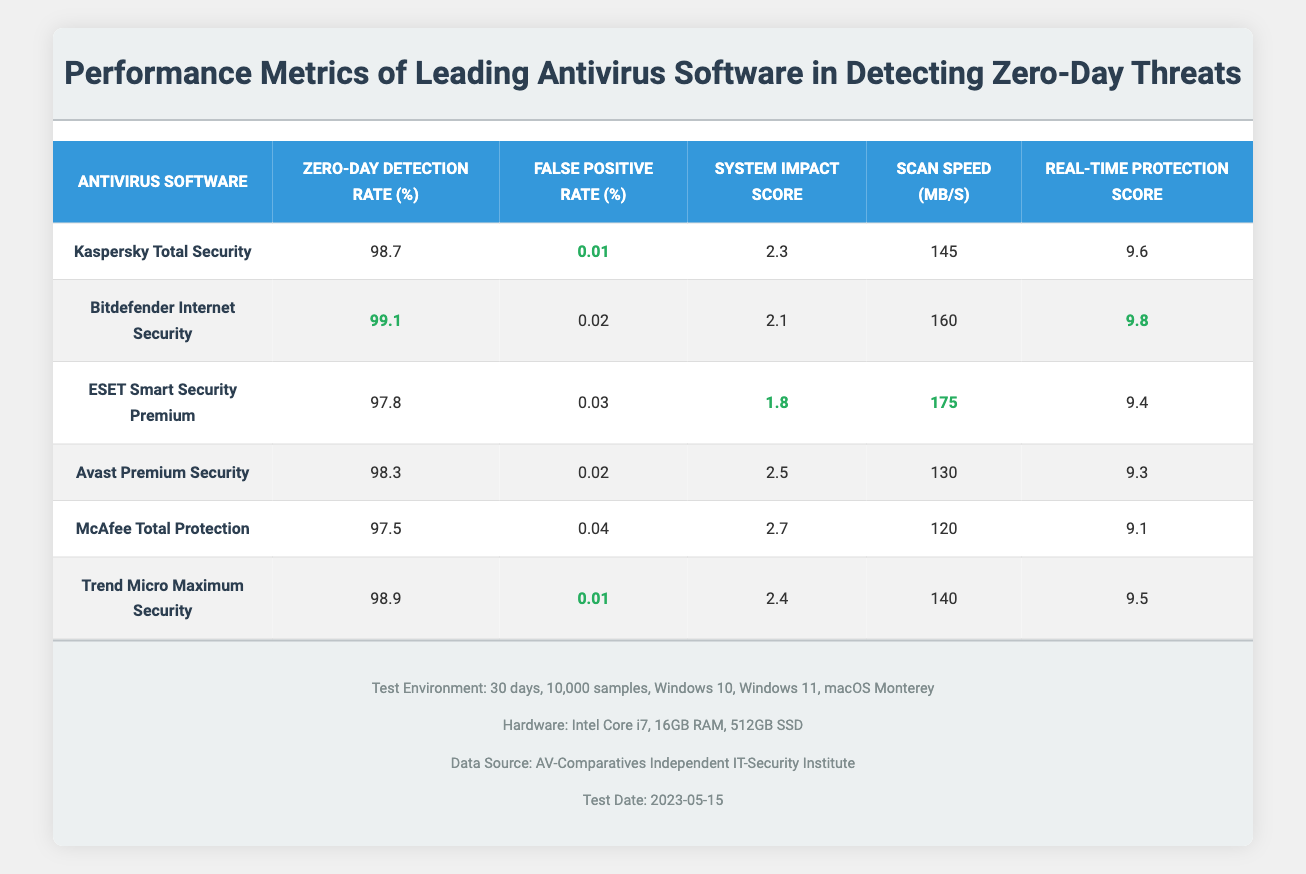what is the zero-day detection rate of Bitdefender Internet Security? The table lists the zero-day detection rate for each antivirus software. For Bitdefender Internet Security, the corresponding value is 99.1% as shown in the table.
Answer: 99.1% which antivirus software has the highest real-time protection score? The real-time protection score for each antivirus software is listed in the table. Upon reviewing these scores, Bitdefender Internet Security has the highest score of 9.8.
Answer: Bitdefender Internet Security is the false positive rate for Kaspersky Total Security lower than that of ESET Smart Security Premium? Kaspersky Total Security has a false positive rate of 0.01%, while ESET Smart Security Premium has a false positive rate of 0.03%. Since 0.01% is less than 0.03%, the statement is true.
Answer: Yes what is the average scan speed of the antivirus software in the table? To find the average scan speed, we sum the scan speeds of all antivirus software: (145 + 160 + 175 + 130 + 120 + 140) = 970. There are 6 entries, so we divide 970 by 6, resulting in an average of approximately 161.67 MB/s.
Answer: 161.67 MB/s which antivirus software has the lowest system impact score? The system impact scores for each software are indicated in the table. ESET Smart Security Premium has the lowest score of 1.8.
Answer: ESET Smart Security Premium is the zero-day detection rate of Avast Premium Security above 98%? The table indicates that Avast Premium Security has a zero-day detection rate of 98.3%, which is above 98%. Thus, the statement is true.
Answer: Yes what is the difference in the zero-day detection rates between Trend Micro Maximum Security and McAfee Total Protection? From the table, Trend Micro Maximum Security has a detection rate of 98.9%, while McAfee Total Protection has a detection rate of 97.5%. The difference is calculated as 98.9 - 97.5 = 1.4%.
Answer: 1.4% how many antivirus programs have a false positive rate of 0.01%? The table shows that both Kaspersky Total Security and Trend Micro Maximum Security have a false positive rate of 0.01%. Therefore, there are two antivirus programs with this rate.
Answer: 2 which antivirus software has both the highest zero-day detection rate and the highest real-time protection score? By examining the table, Bitdefender Internet Security holds the highest zero-day detection rate at 99.1% and also has the highest real-time protection score of 9.8. Thus, it is the software that meets both criteria.
Answer: Bitdefender Internet Security 